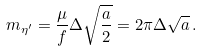Convert formula to latex. <formula><loc_0><loc_0><loc_500><loc_500>m _ { \eta ^ { \prime } } = \frac { \mu } { f } \Delta \sqrt { \frac { a } { 2 } } = 2 \pi \Delta \sqrt { a } \, .</formula> 